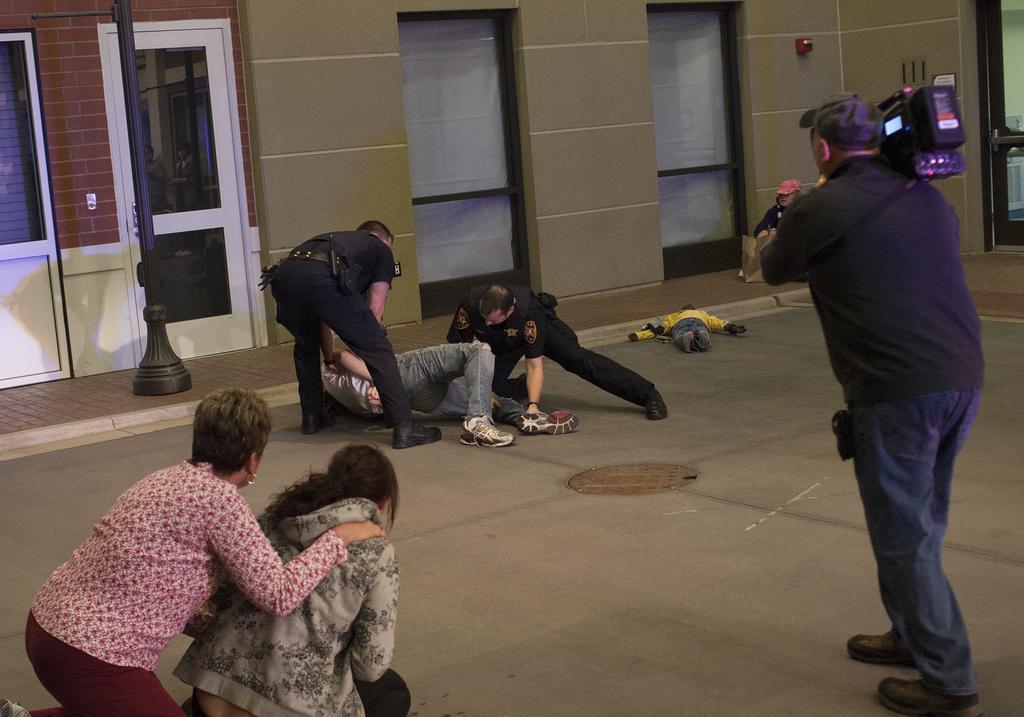Could you give a brief overview of what you see in this image? On the left side, there are two persons. On the right side, there is a person holding a camera on a floor. In the background, there are two persons in a uniform, holding a person. Beside them, there is a person lying and a pole on a footpath. Beside this footpath, there is a building which is having doors. 